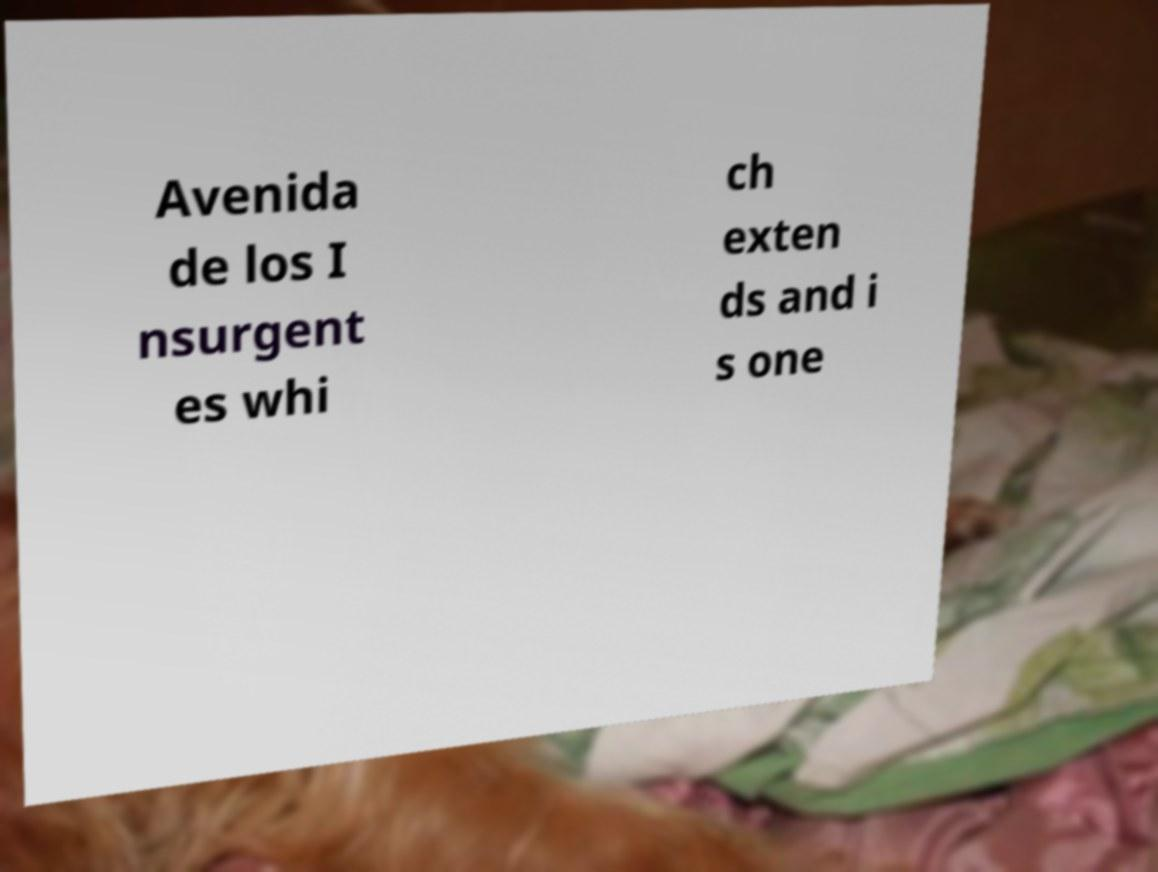Could you assist in decoding the text presented in this image and type it out clearly? Avenida de los I nsurgent es whi ch exten ds and i s one 